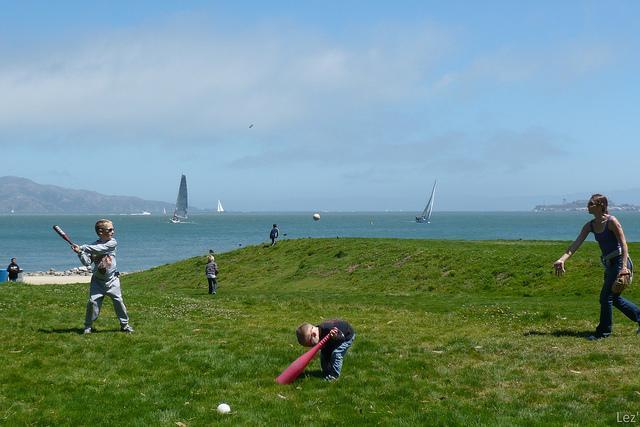How many people are in the picture?
Give a very brief answer. 2. 